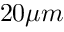<formula> <loc_0><loc_0><loc_500><loc_500>2 0 \mu m</formula> 